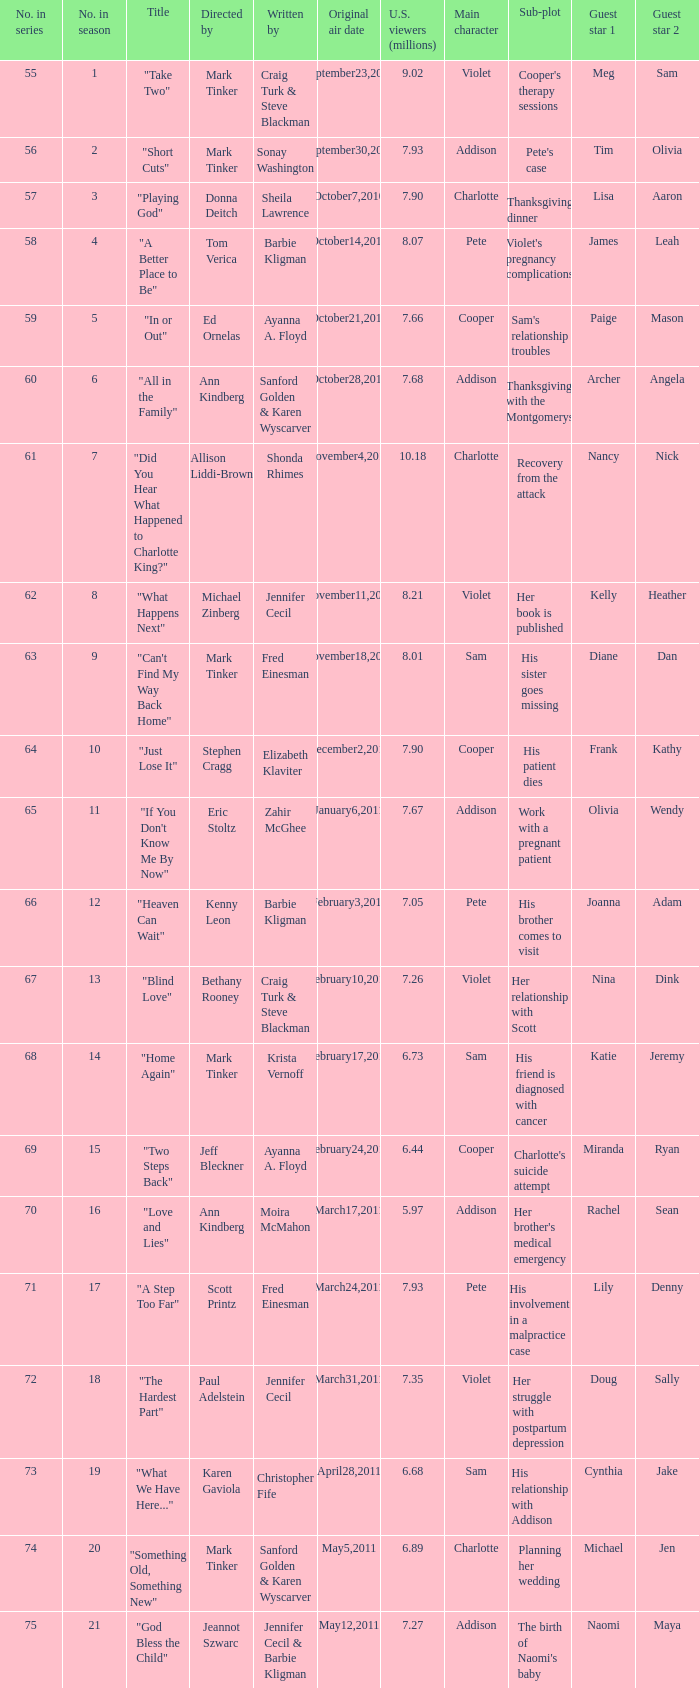What number episode in the season was directed by Paul Adelstein?  18.0. 